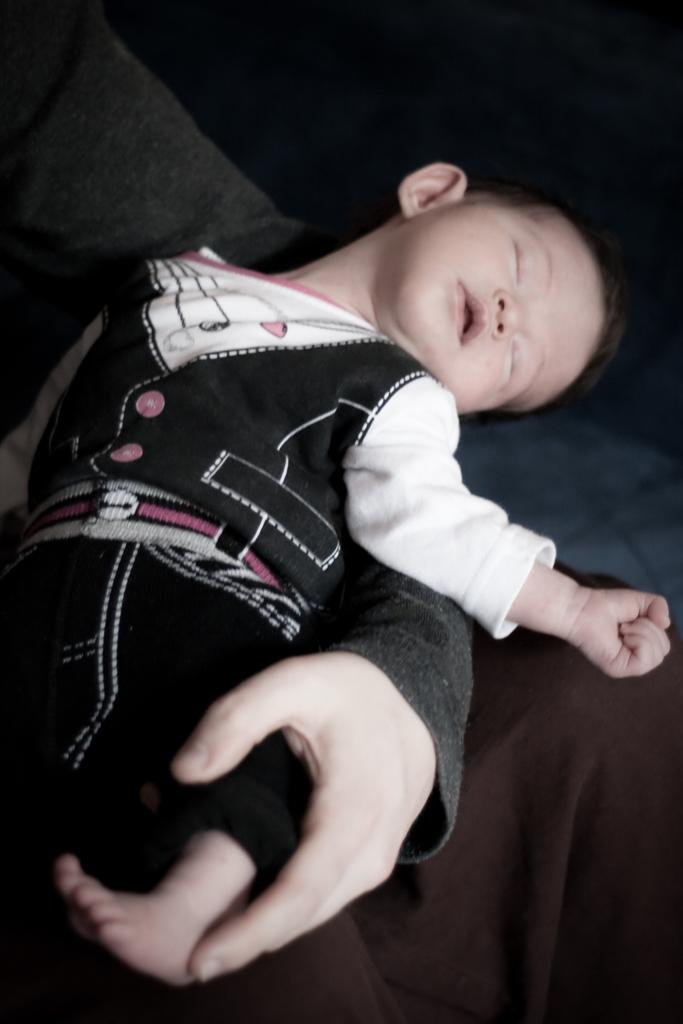What is the main subject of the image? The main subject of the image is a baby boy. What is the baby boy doing in the image? The baby boy is sleeping in the image. What is the baby boy wearing in the image? The baby boy is wearing a black dress in the image. What type of pet can be seen sleeping next to the baby boy in the image? There is no pet present in the image; it only features the baby boy sleeping. 